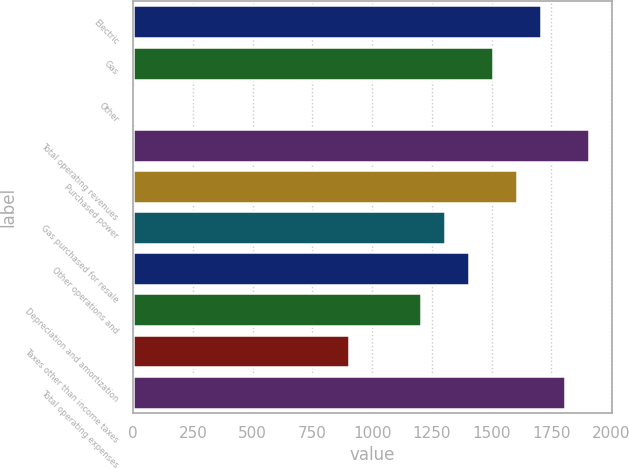Convert chart. <chart><loc_0><loc_0><loc_500><loc_500><bar_chart><fcel>Electric<fcel>Gas<fcel>Other<fcel>Total operating revenues<fcel>Purchased power<fcel>Gas purchased for resale<fcel>Other operations and<fcel>Depreciation and amortization<fcel>Taxes other than income taxes<fcel>Total operating expenses<nl><fcel>1706.4<fcel>1506<fcel>3<fcel>1906.8<fcel>1606.2<fcel>1305.6<fcel>1405.8<fcel>1205.4<fcel>904.8<fcel>1806.6<nl></chart> 